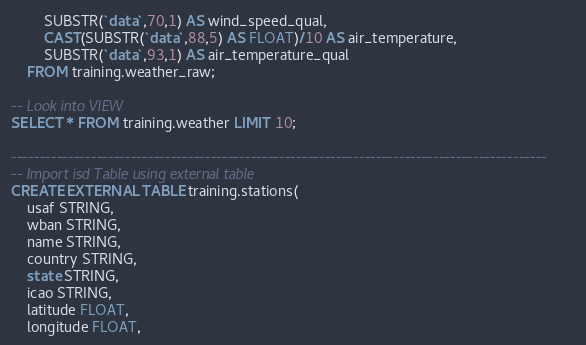<code> <loc_0><loc_0><loc_500><loc_500><_SQL_>        SUBSTR(`data`,70,1) AS wind_speed_qual,
        CAST(SUBSTR(`data`,88,5) AS FLOAT)/10 AS air_temperature, 
        SUBSTR(`data`,93,1) AS air_temperature_qual 
    FROM training.weather_raw;

-- Look into VIEW
SELECT * FROM training.weather LIMIT 10;

----------------------------------------------------------------------------------------------
-- Import isd Table using external table
CREATE EXTERNAL TABLE training.stations(
    usaf STRING,
    wban STRING,
    name STRING,
    country STRING,
    state STRING,
    icao STRING,
    latitude FLOAT,
    longitude FLOAT,</code> 